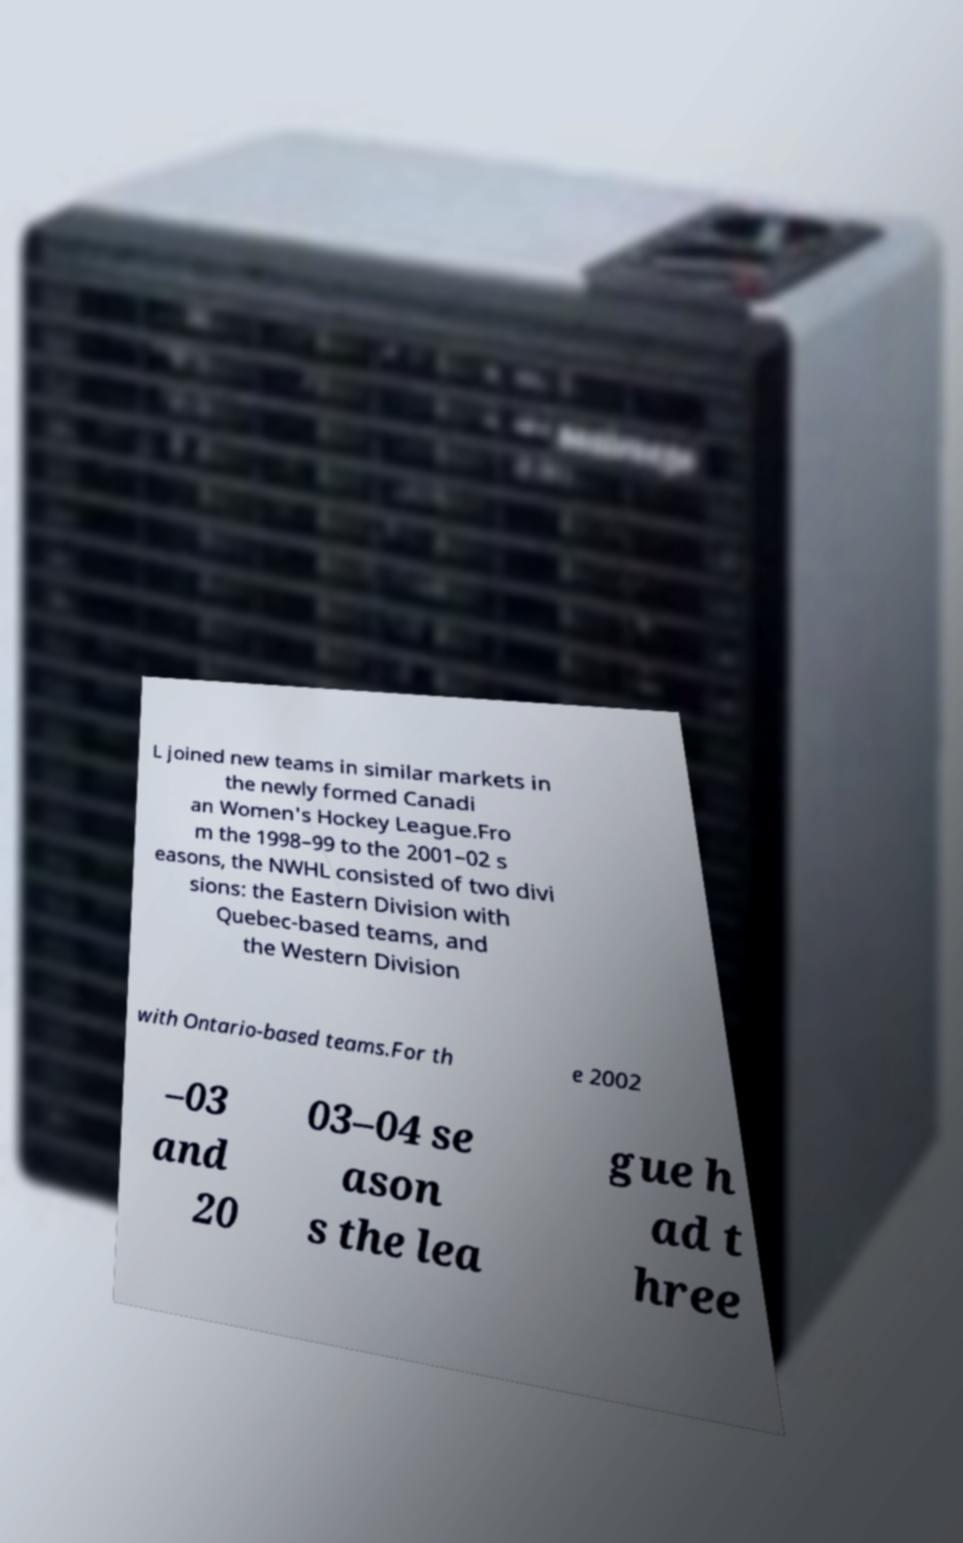Please read and relay the text visible in this image. What does it say? L joined new teams in similar markets in the newly formed Canadi an Women's Hockey League.Fro m the 1998–99 to the 2001–02 s easons, the NWHL consisted of two divi sions: the Eastern Division with Quebec-based teams, and the Western Division with Ontario-based teams.For th e 2002 –03 and 20 03–04 se ason s the lea gue h ad t hree 